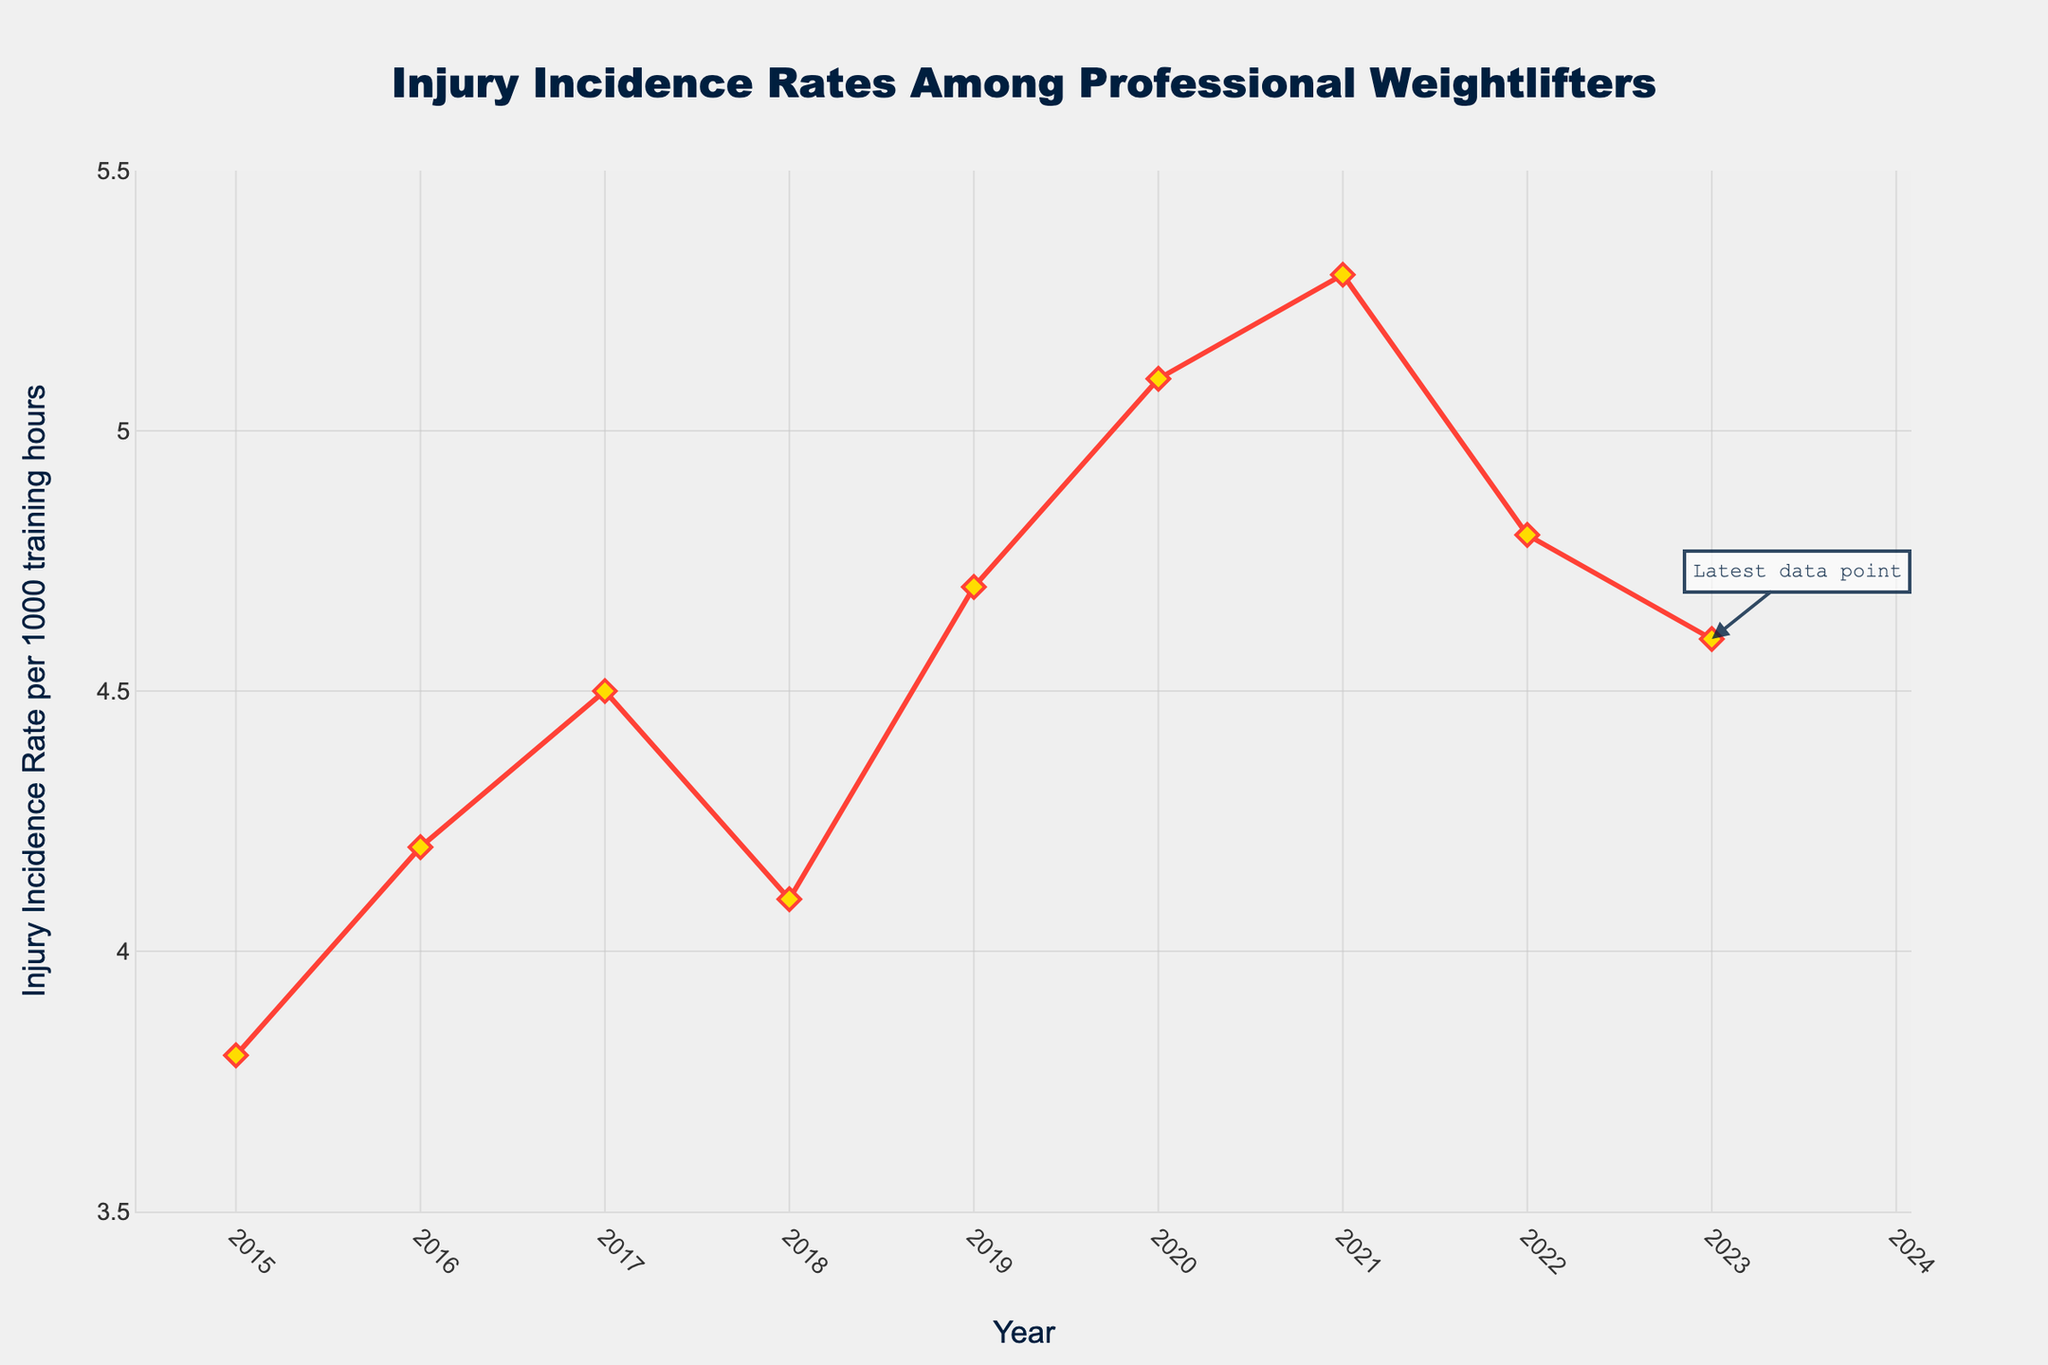what is the title of the plot? The title is located at the top center of the plot and it reads "Injury Incidence Rates Among Professional Weightlifters".
Answer: Injury Incidence Rates Among Professional Weightlifters how many years of data are plotted? The x-axis represents years from 2015 to 2023, which includes 9 data points.
Answer: 9 what is the color of the line used in the plot? The line in the plot is colored in red.
Answer: red What was the injury incidence rate in 2020? Look at the data point for the year 2020; the corresponding rate marked on the y-axis is 5.1.
Answer: 5.1 In which year was the injury incidence rate the highest? The highest data point on the y-axis corresponds to 2021, which is 5.3.
Answer: 2021 What is the difference in injury incidence rates between 2015 and 2023? The rate in 2015 is 3.8 and the rate in 2023 is 4.6. The difference is 4.6 - 3.8 = 0.8.
Answer: 0.8 What is the average injury incidence rate from 2015 to 2023? Sum all the rates (3.8 + 4.2 + 4.5 + 4.1 + 4.7 + 5.1 + 5.3 + 4.8 + 4.6) = 41.1. Divide by the number of years (9). 41.1 / 9 ≈ 4.57.
Answer: 4.57 By how much did the injury incidence rate increase from 2015 to 2019? The rate in 2015 is 3.8, and in 2019 it is 4.7. The increase is 4.7 - 3.8 = 0.9.
Answer: 0.9 Is the overall trend of the injury incidence rate increasing or decreasing over the period shown? Observe the general direction of the line from 2015 to 2023; it starts at 3.8 and ends at 4.6 with some fluctuations but trends upward overall.
Answer: Increasing 